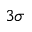Convert formula to latex. <formula><loc_0><loc_0><loc_500><loc_500>3 \sigma</formula> 